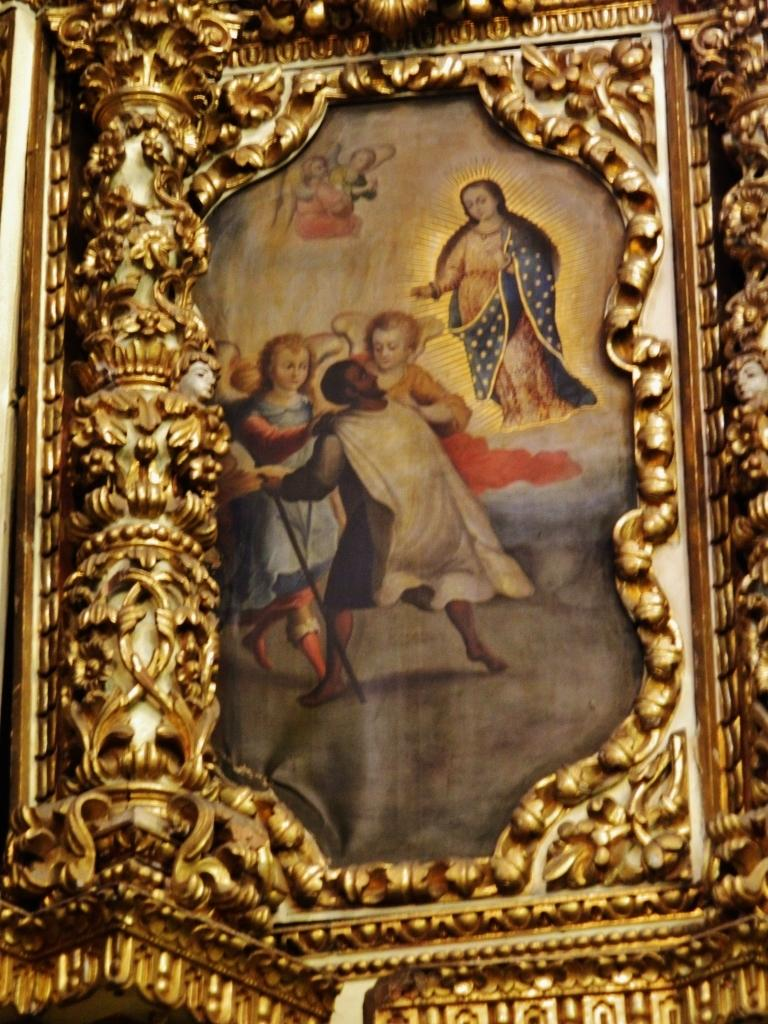What is the main subject in the center of the image? There is a photo frame in the center of the image. What can be seen inside the photo frame? There are persons in the photo frame. What type of copper material is used to make the pear in the image? There is no copper or pear present in the image; it only features a photo frame with persons inside. 